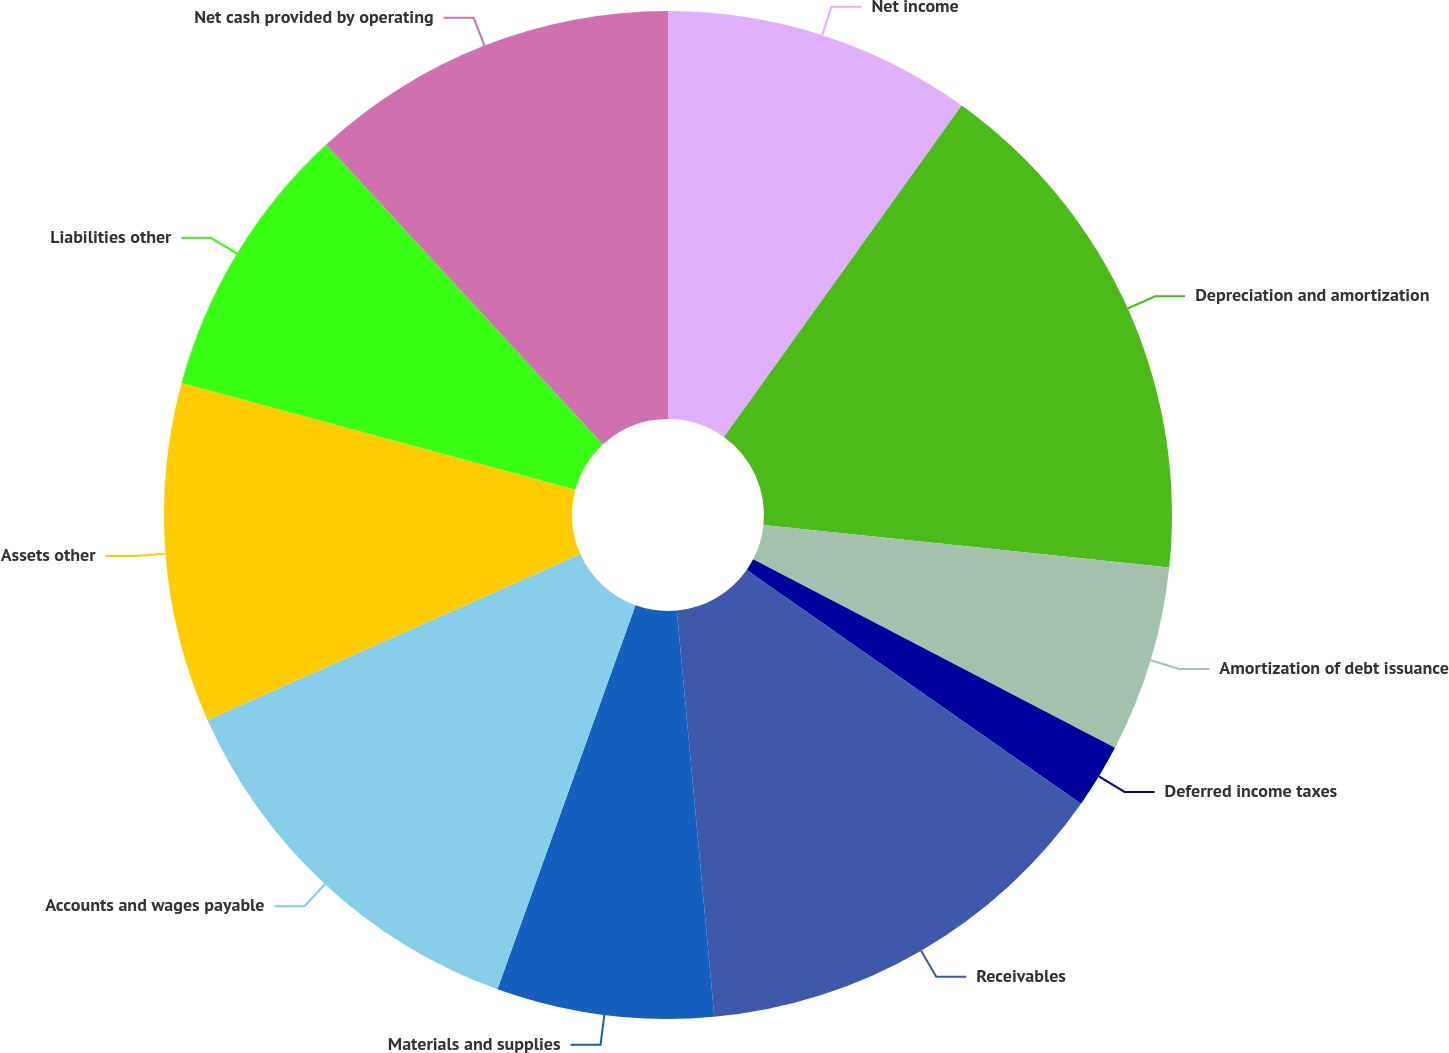Convert chart to OTSL. <chart><loc_0><loc_0><loc_500><loc_500><pie_chart><fcel>Net income<fcel>Depreciation and amortization<fcel>Amortization of debt issuance<fcel>Deferred income taxes<fcel>Receivables<fcel>Materials and supplies<fcel>Accounts and wages payable<fcel>Assets other<fcel>Liabilities other<fcel>Net cash provided by operating<nl><fcel>9.9%<fcel>16.76%<fcel>5.98%<fcel>2.07%<fcel>13.82%<fcel>6.96%<fcel>12.84%<fcel>10.88%<fcel>8.92%<fcel>11.86%<nl></chart> 